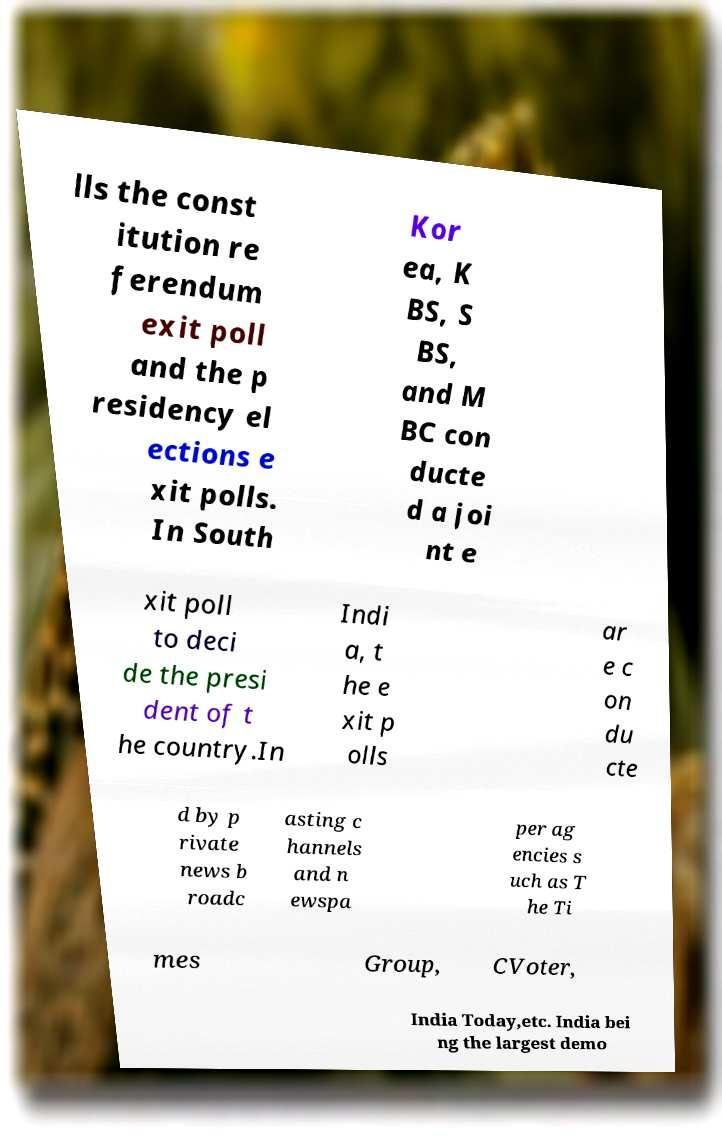Could you assist in decoding the text presented in this image and type it out clearly? lls the const itution re ferendum exit poll and the p residency el ections e xit polls. In South Kor ea, K BS, S BS, and M BC con ducte d a joi nt e xit poll to deci de the presi dent of t he country.In Indi a, t he e xit p olls ar e c on du cte d by p rivate news b roadc asting c hannels and n ewspa per ag encies s uch as T he Ti mes Group, CVoter, India Today,etc. India bei ng the largest demo 